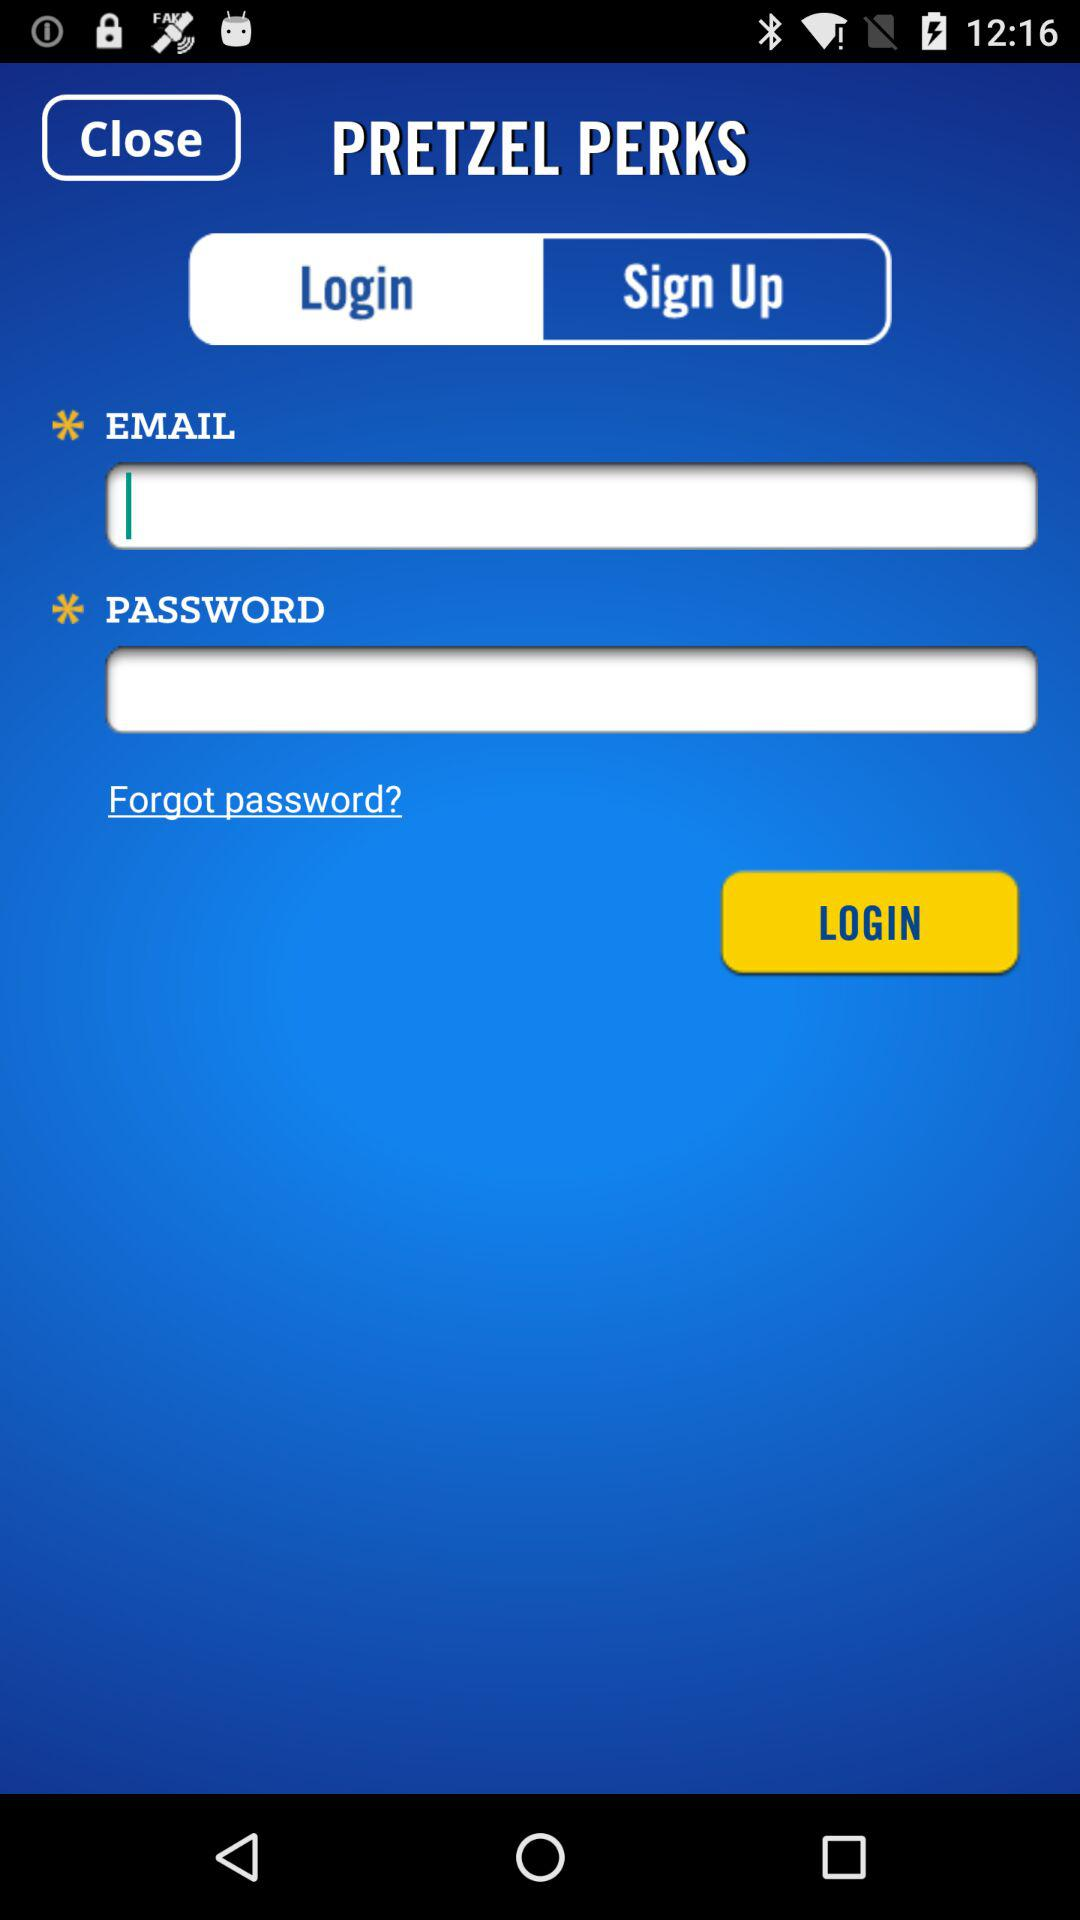Which tab am I using? You are using the "Login" tab. 